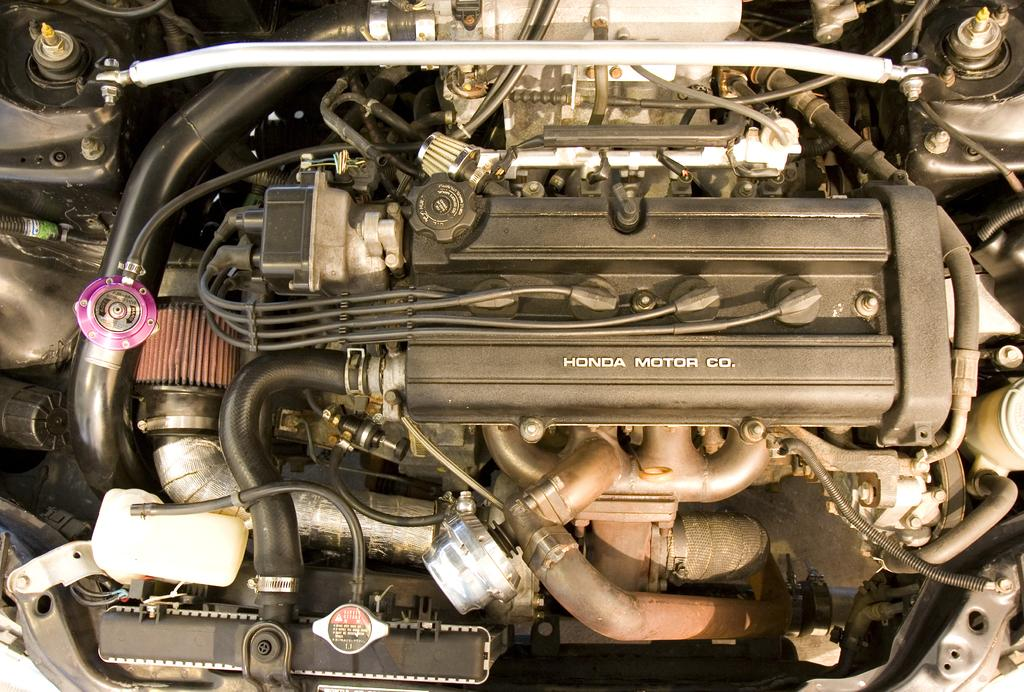What type of object is depicted in the image? The image contains parts of a vehicle. What is a key component of the vehicle? The vehicle has an engine. What type of infrastructure is present in the image? There are pipes and cables in the image. What is the rod used for in the image? The purpose of the rod in the image is not specified, but it is likely a structural or functional component of the vehicle. Where is the bucket located in the image? There is no bucket present in the image. What type of berries can be seen growing near the vehicle in the image? There are no berries visible in the image. 